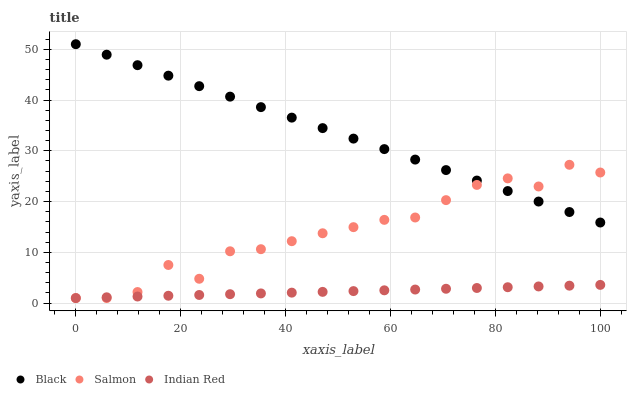Does Indian Red have the minimum area under the curve?
Answer yes or no. Yes. Does Black have the maximum area under the curve?
Answer yes or no. Yes. Does Black have the minimum area under the curve?
Answer yes or no. No. Does Indian Red have the maximum area under the curve?
Answer yes or no. No. Is Indian Red the smoothest?
Answer yes or no. Yes. Is Salmon the roughest?
Answer yes or no. Yes. Is Black the smoothest?
Answer yes or no. No. Is Black the roughest?
Answer yes or no. No. Does Salmon have the lowest value?
Answer yes or no. Yes. Does Black have the lowest value?
Answer yes or no. No. Does Black have the highest value?
Answer yes or no. Yes. Does Indian Red have the highest value?
Answer yes or no. No. Is Indian Red less than Black?
Answer yes or no. Yes. Is Black greater than Indian Red?
Answer yes or no. Yes. Does Black intersect Salmon?
Answer yes or no. Yes. Is Black less than Salmon?
Answer yes or no. No. Is Black greater than Salmon?
Answer yes or no. No. Does Indian Red intersect Black?
Answer yes or no. No. 